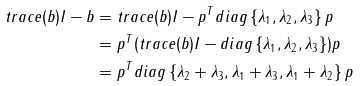Convert formula to latex. <formula><loc_0><loc_0><loc_500><loc_500>t r a c e ( b ) I - b & = t r a c e ( b ) I - p ^ { T } d i a g \left \{ \lambda _ { 1 } , \lambda _ { 2 } , \lambda _ { 3 } \right \} p \\ & = p ^ { T } ( t r a c e ( b ) I - d i a g \left \{ \lambda _ { 1 } , \lambda _ { 2 } , \lambda _ { 3 } \right \} ) p \\ & = p ^ { T } d i a g \left \{ \lambda _ { 2 } + \lambda _ { 3 } , \lambda _ { 1 } + \lambda _ { 3 } , \lambda _ { 1 } + \lambda _ { 2 } \right \} p</formula> 